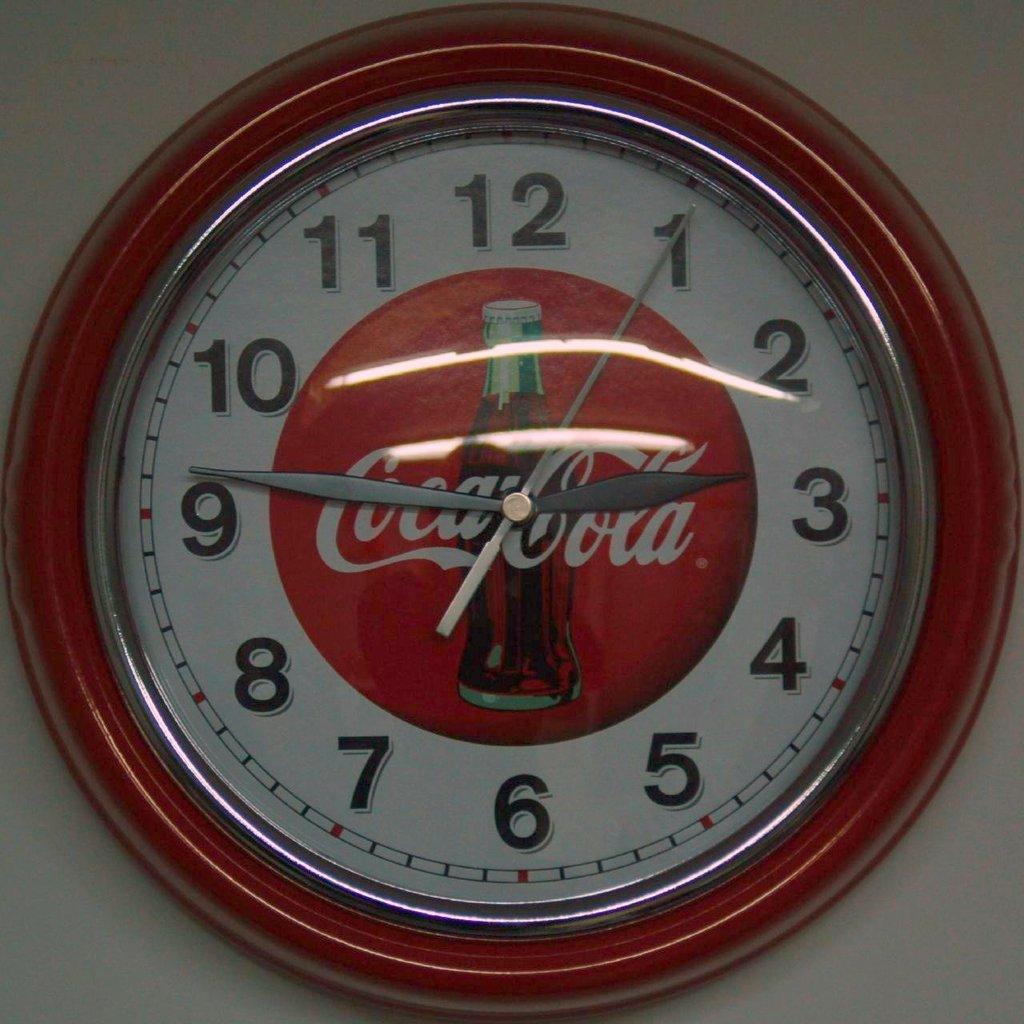What time does it read on this clock?
Keep it short and to the point. 2:46. What is the brand advertised on this clock?
Offer a very short reply. Coca-cola. 